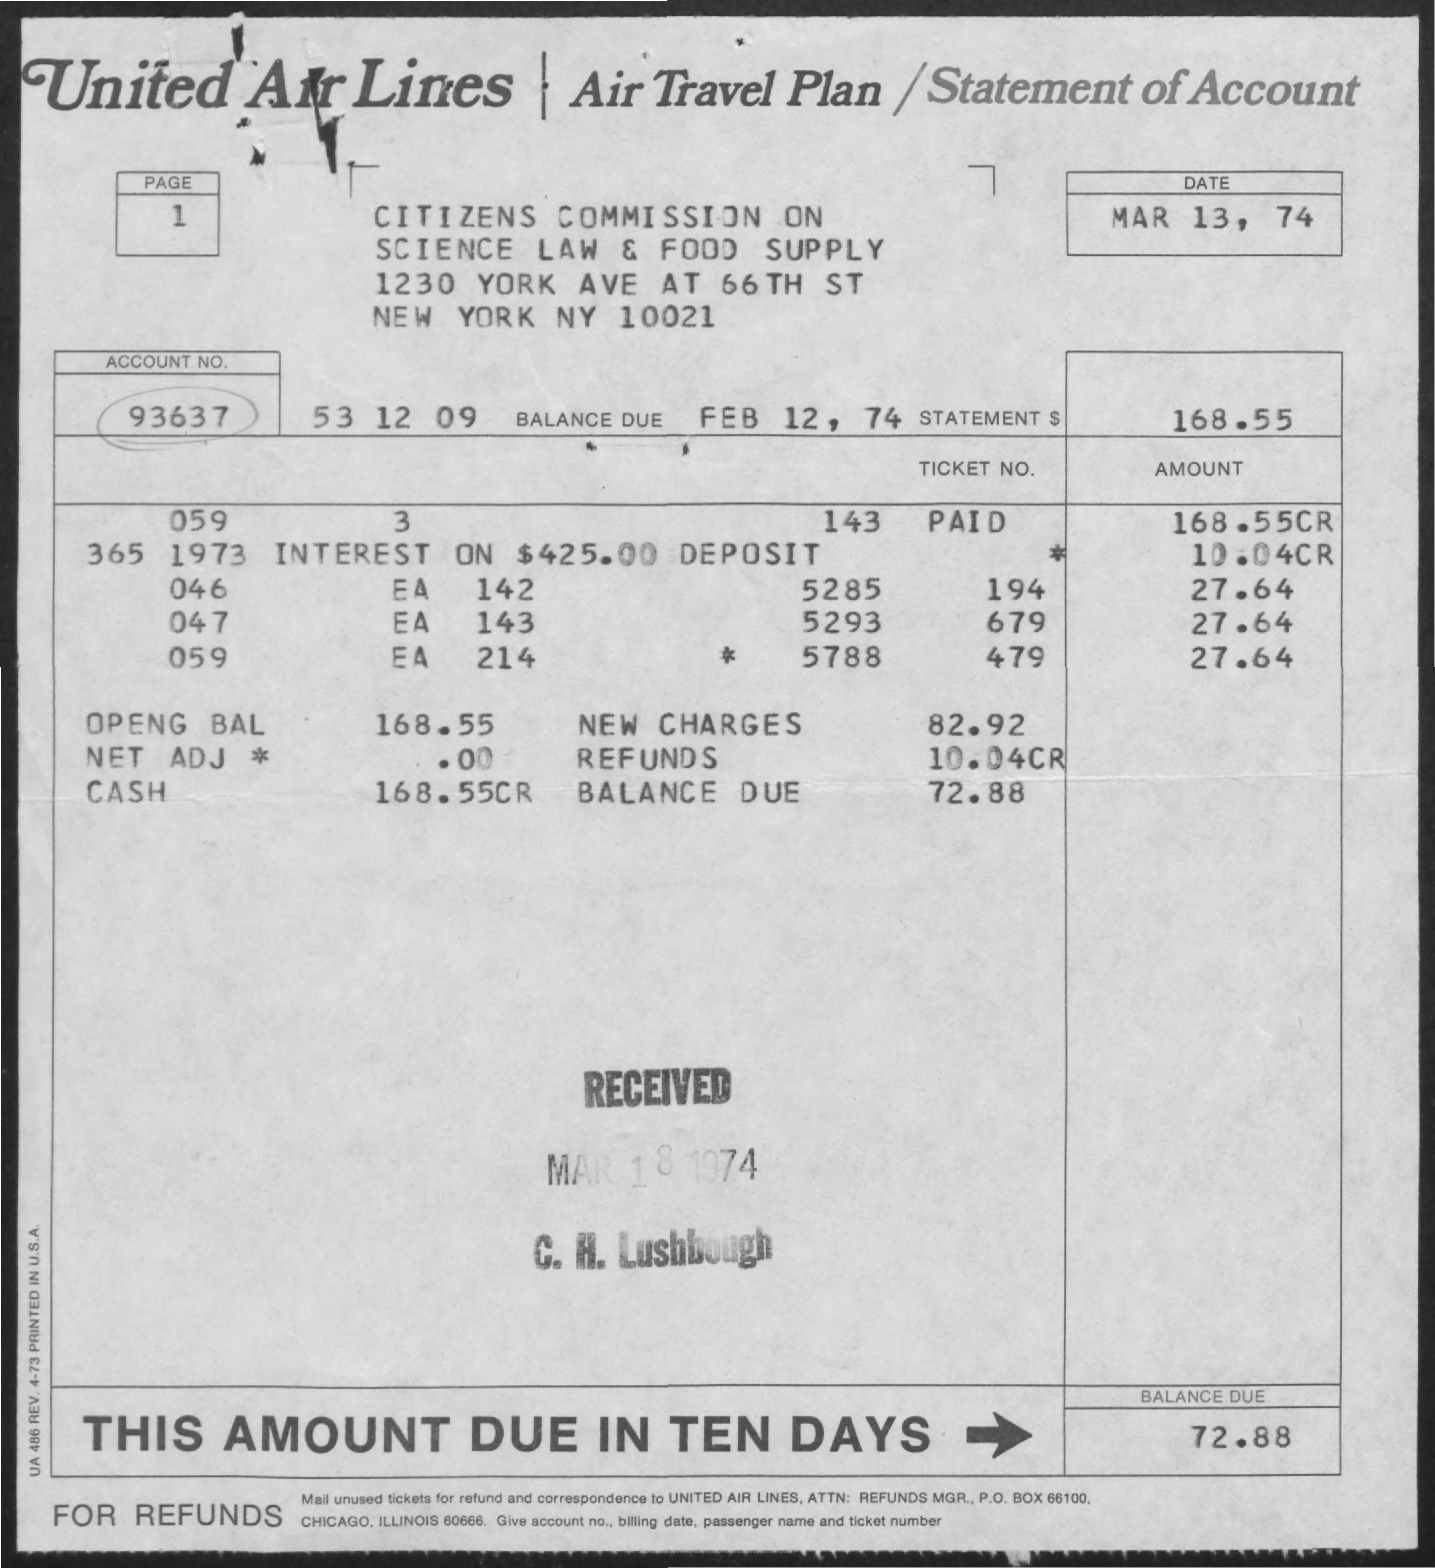Identify some key points in this picture. I would like to know the account number, specifically 93637... The document is dated March 13, 1774. The balance is due on February 12, 1774. The balance due in ten days is $100. The company named United Air Lines is mentioned. 